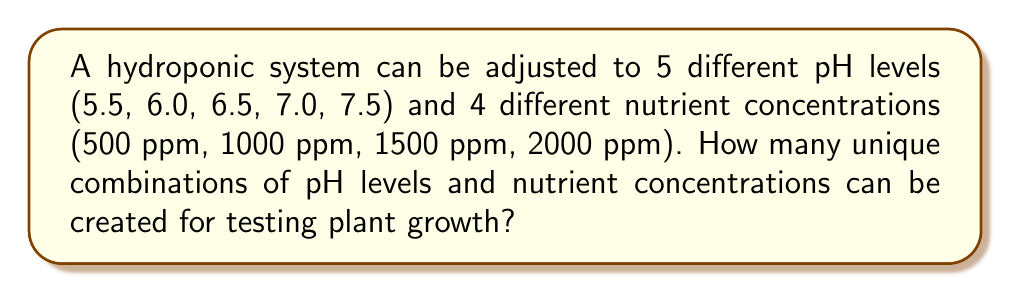Teach me how to tackle this problem. To solve this problem, we need to use the multiplication principle of counting. This principle states that if we have two independent events, the total number of possible outcomes is the product of the number of possibilities for each event.

In this case, we have:
1. pH levels: 5 options
2. Nutrient concentrations: 4 options

These are independent choices, as the selection of a pH level does not affect the selection of a nutrient concentration, and vice versa.

Therefore, the total number of unique combinations is:

$$ \text{Total combinations} = \text{Number of pH levels} \times \text{Number of nutrient concentrations} $$

$$ \text{Total combinations} = 5 \times 4 = 20 $$

This means that there are 20 different ways to combine the pH levels and nutrient concentrations for testing plant growth in the hydroponic system.
Answer: 20 combinations 